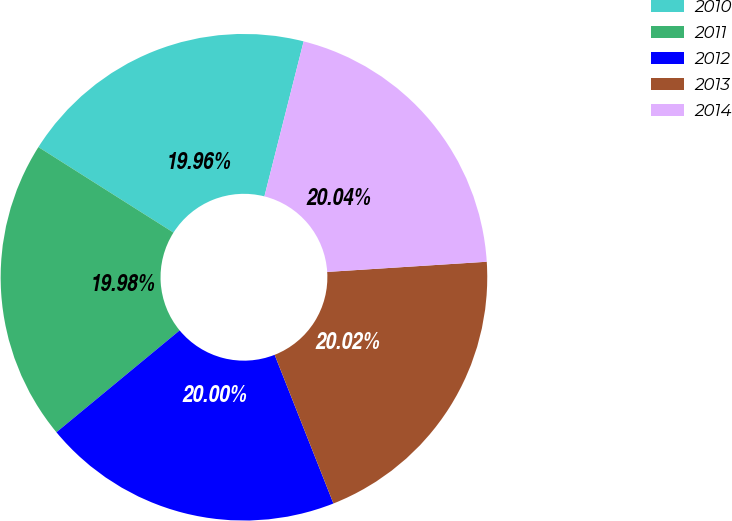Convert chart. <chart><loc_0><loc_0><loc_500><loc_500><pie_chart><fcel>2010<fcel>2011<fcel>2012<fcel>2013<fcel>2014<nl><fcel>19.96%<fcel>19.98%<fcel>20.0%<fcel>20.02%<fcel>20.04%<nl></chart> 